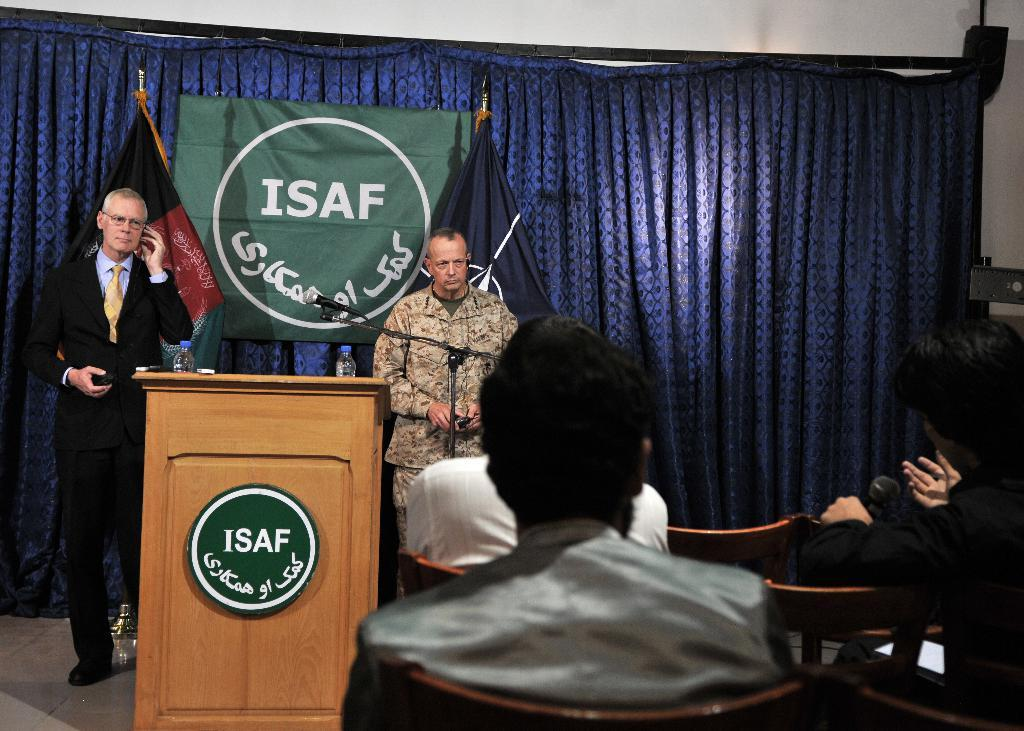Provide a one-sentence caption for the provided image. A podium and banner with a white circle on a green background and white letters ISAF, with two men standing between them. 